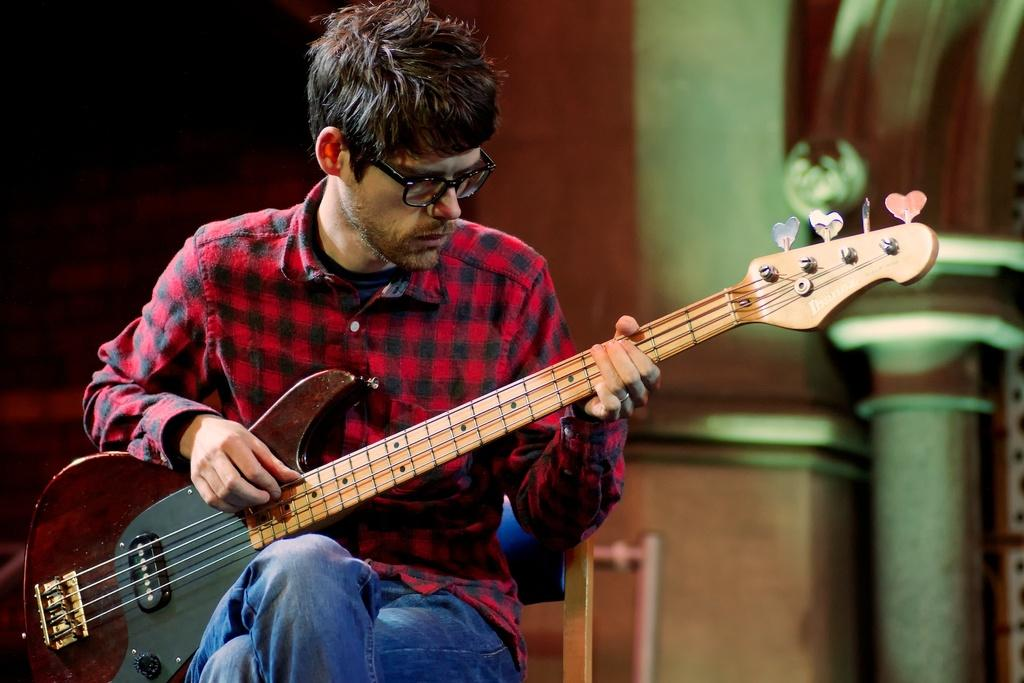What is the man in the image doing? The man is holding a guitar and playing it with his right hand. What is the man wearing in the image? The man is wearing a red color shirt. Can you describe any accessories the man is wearing in the image? The man has spectacles. What is the man sitting on in the image? The man is sitting on a chair. What type of support can be seen in the cemetery in the image? There is no cemetery or support present in the image; it features a man playing a guitar while sitting on a chair. 